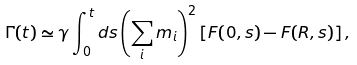Convert formula to latex. <formula><loc_0><loc_0><loc_500><loc_500>\Gamma ( t ) \simeq \gamma \int _ { 0 } ^ { t } d s \left ( \sum _ { i } m _ { i } \right ) ^ { 2 } \left [ F ( 0 , s ) - F ( R , s ) \right ] ,</formula> 